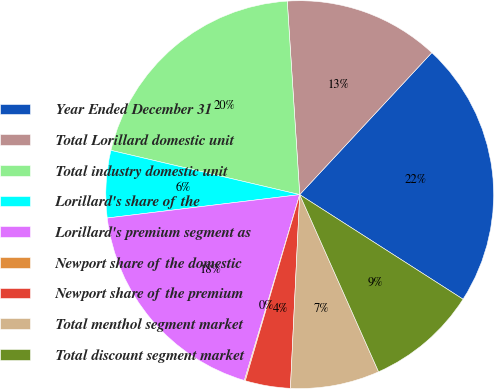<chart> <loc_0><loc_0><loc_500><loc_500><pie_chart><fcel>Year Ended December 31<fcel>Total Lorillard domestic unit<fcel>Total industry domestic unit<fcel>Lorillard's share of the<fcel>Lorillard's premium segment as<fcel>Newport share of the domestic<fcel>Newport share of the premium<fcel>Total menthol segment market<fcel>Total discount segment market<nl><fcel>22.14%<fcel>12.95%<fcel>20.31%<fcel>5.59%<fcel>18.47%<fcel>0.08%<fcel>3.76%<fcel>7.43%<fcel>9.27%<nl></chart> 